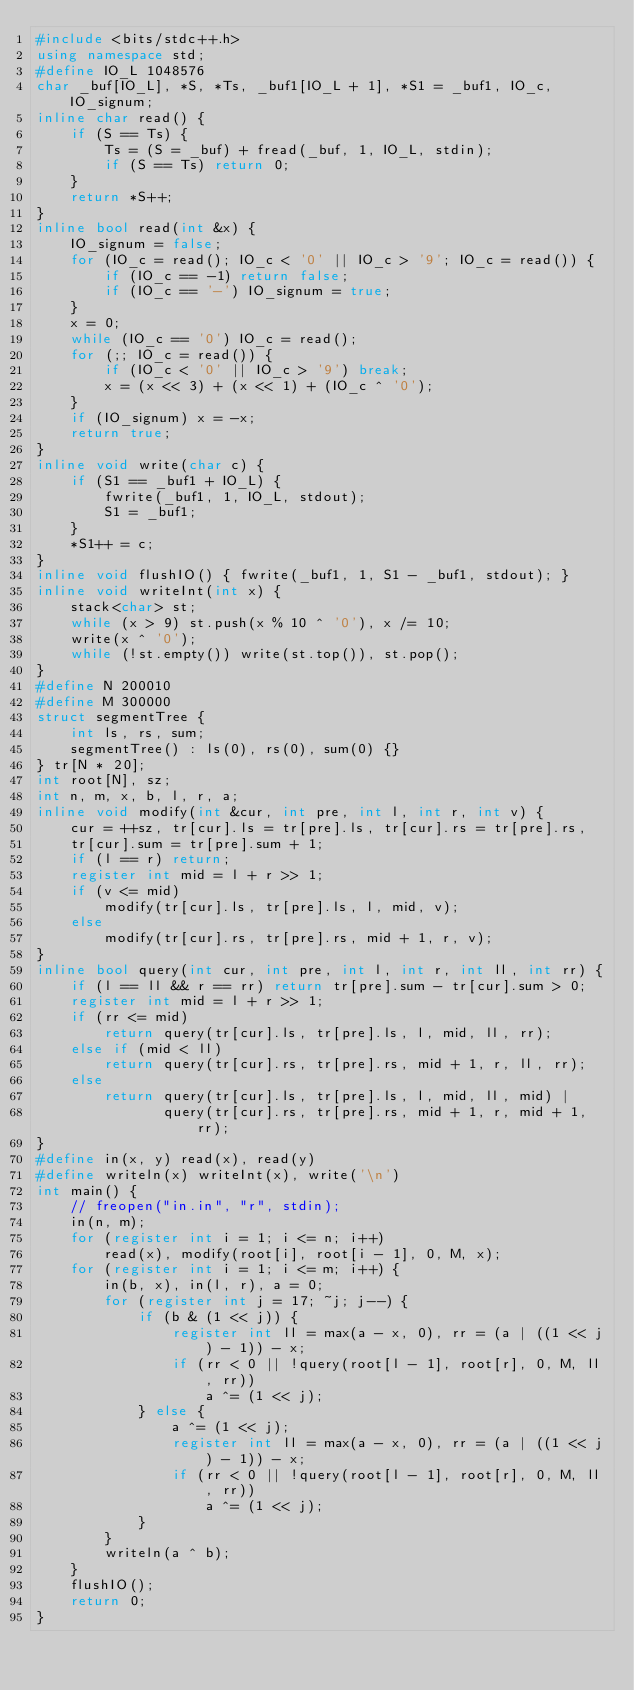Convert code to text. <code><loc_0><loc_0><loc_500><loc_500><_C++_>#include <bits/stdc++.h>
using namespace std;
#define IO_L 1048576
char _buf[IO_L], *S, *Ts, _buf1[IO_L + 1], *S1 = _buf1, IO_c, IO_signum;
inline char read() {
    if (S == Ts) {
        Ts = (S = _buf) + fread(_buf, 1, IO_L, stdin);
        if (S == Ts) return 0;
    }
    return *S++;
}
inline bool read(int &x) {
    IO_signum = false;
    for (IO_c = read(); IO_c < '0' || IO_c > '9'; IO_c = read()) {
        if (IO_c == -1) return false;
        if (IO_c == '-') IO_signum = true;
    }
    x = 0;
    while (IO_c == '0') IO_c = read();
    for (;; IO_c = read()) {
        if (IO_c < '0' || IO_c > '9') break;
        x = (x << 3) + (x << 1) + (IO_c ^ '0');
    }
    if (IO_signum) x = -x;
    return true;
}
inline void write(char c) {
    if (S1 == _buf1 + IO_L) {
        fwrite(_buf1, 1, IO_L, stdout);
        S1 = _buf1;
    }
    *S1++ = c;
}
inline void flushIO() { fwrite(_buf1, 1, S1 - _buf1, stdout); }
inline void writeInt(int x) {
    stack<char> st;
    while (x > 9) st.push(x % 10 ^ '0'), x /= 10;
    write(x ^ '0');
    while (!st.empty()) write(st.top()), st.pop();
}
#define N 200010
#define M 300000
struct segmentTree {
    int ls, rs, sum;
    segmentTree() : ls(0), rs(0), sum(0) {}
} tr[N * 20];
int root[N], sz;
int n, m, x, b, l, r, a;
inline void modify(int &cur, int pre, int l, int r, int v) {
    cur = ++sz, tr[cur].ls = tr[pre].ls, tr[cur].rs = tr[pre].rs,
    tr[cur].sum = tr[pre].sum + 1;
    if (l == r) return;
    register int mid = l + r >> 1;
    if (v <= mid)
        modify(tr[cur].ls, tr[pre].ls, l, mid, v);
    else
        modify(tr[cur].rs, tr[pre].rs, mid + 1, r, v);
}
inline bool query(int cur, int pre, int l, int r, int ll, int rr) {
    if (l == ll && r == rr) return tr[pre].sum - tr[cur].sum > 0;
    register int mid = l + r >> 1;
    if (rr <= mid)
        return query(tr[cur].ls, tr[pre].ls, l, mid, ll, rr);
    else if (mid < ll)
        return query(tr[cur].rs, tr[pre].rs, mid + 1, r, ll, rr);
    else
        return query(tr[cur].ls, tr[pre].ls, l, mid, ll, mid) |
               query(tr[cur].rs, tr[pre].rs, mid + 1, r, mid + 1, rr);
}
#define in(x, y) read(x), read(y)
#define writeln(x) writeInt(x), write('\n')
int main() {
    // freopen("in.in", "r", stdin);
    in(n, m);
    for (register int i = 1; i <= n; i++)
        read(x), modify(root[i], root[i - 1], 0, M, x);
    for (register int i = 1; i <= m; i++) {
        in(b, x), in(l, r), a = 0;
        for (register int j = 17; ~j; j--) {
            if (b & (1 << j)) {
                register int ll = max(a - x, 0), rr = (a | ((1 << j) - 1)) - x;
                if (rr < 0 || !query(root[l - 1], root[r], 0, M, ll, rr))
                    a ^= (1 << j);
            } else {
                a ^= (1 << j);
                register int ll = max(a - x, 0), rr = (a | ((1 << j) - 1)) - x;
                if (rr < 0 || !query(root[l - 1], root[r], 0, M, ll, rr))
                    a ^= (1 << j);
            }
        }
        writeln(a ^ b);
    }
    flushIO();
    return 0;
}</code> 